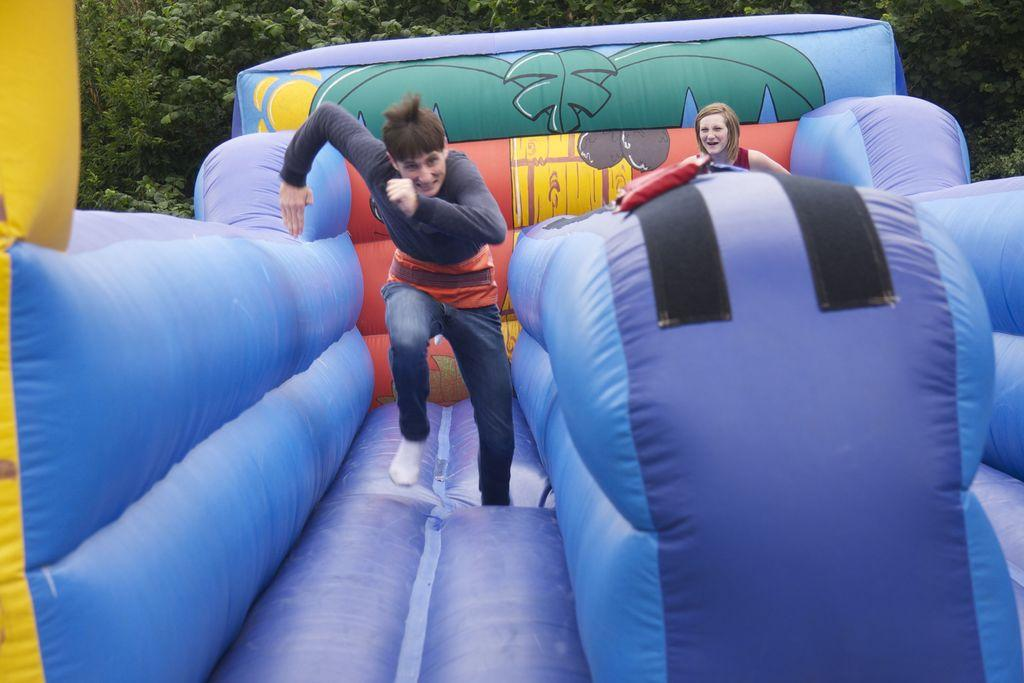What is the man in the image doing? The man is running on an inflatable object. Who else is present in the image? There is a girl in the image. What is the girl doing in the image? The girl is standing on the inflatable object. What can be seen in the background of the image? There are trees in the background of the image. What type of paper is the man using to write his lunchroom report in the image? There is no paper or lunchroom report present in the image. 